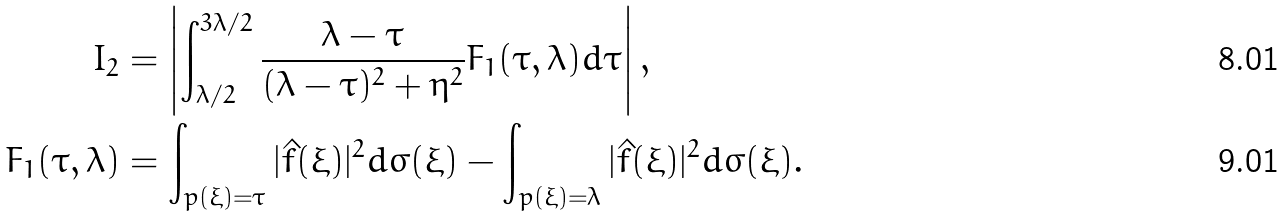<formula> <loc_0><loc_0><loc_500><loc_500>I _ { 2 } & = \left | \int _ { \lambda / 2 } ^ { 3 \lambda / 2 } \frac { \lambda - \tau } { ( \lambda - \tau ) ^ { 2 } + \eta ^ { 2 } } F _ { 1 } ( \tau , \lambda ) d \tau \right | , \\ F _ { 1 } ( \tau , \lambda ) & = \int _ { p ( \xi ) = \tau } | \hat { f } ( \xi ) | ^ { 2 } d \sigma ( \xi ) - \int _ { p ( \xi ) = \lambda } | \hat { f } ( \xi ) | ^ { 2 } d \sigma ( \xi ) .</formula> 